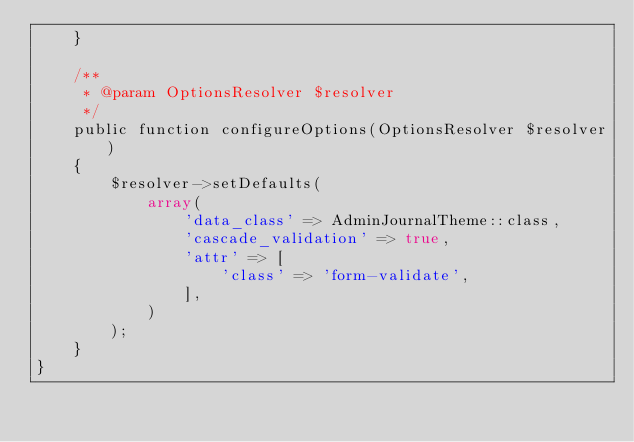Convert code to text. <code><loc_0><loc_0><loc_500><loc_500><_PHP_>    }

    /**
     * @param OptionsResolver $resolver
     */
    public function configureOptions(OptionsResolver $resolver)
    {
        $resolver->setDefaults(
            array(
                'data_class' => AdminJournalTheme::class,
                'cascade_validation' => true,
                'attr' => [
                    'class' => 'form-validate',
                ],
            )
        );
    }
}
</code> 